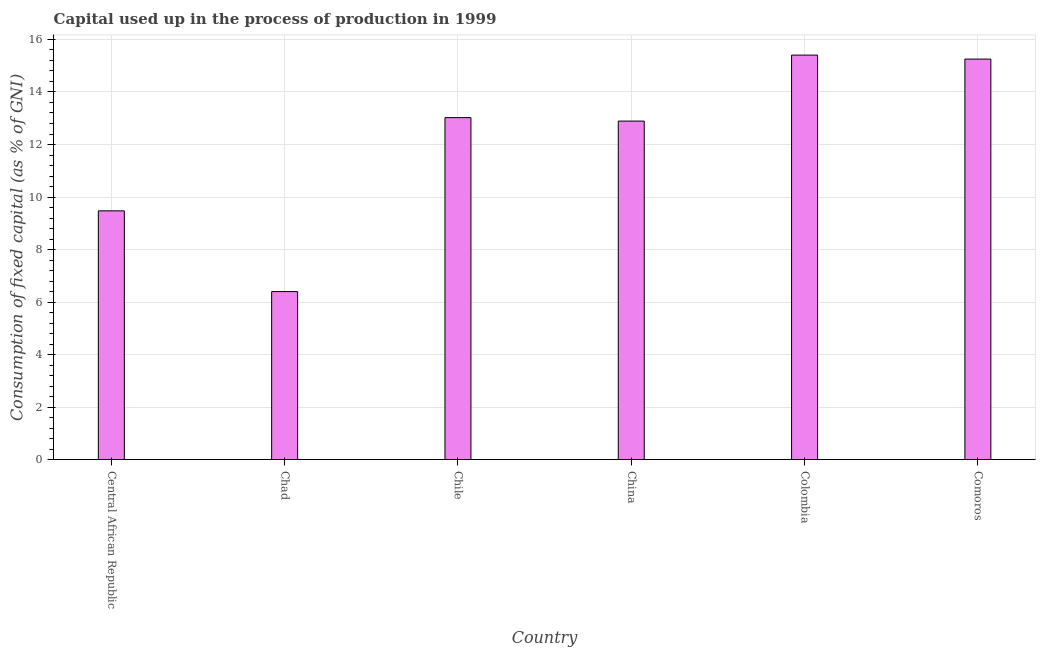Does the graph contain grids?
Keep it short and to the point. Yes. What is the title of the graph?
Offer a terse response. Capital used up in the process of production in 1999. What is the label or title of the Y-axis?
Make the answer very short. Consumption of fixed capital (as % of GNI). What is the consumption of fixed capital in Chad?
Offer a very short reply. 6.4. Across all countries, what is the maximum consumption of fixed capital?
Ensure brevity in your answer.  15.4. Across all countries, what is the minimum consumption of fixed capital?
Your response must be concise. 6.4. In which country was the consumption of fixed capital maximum?
Give a very brief answer. Colombia. In which country was the consumption of fixed capital minimum?
Provide a succinct answer. Chad. What is the sum of the consumption of fixed capital?
Your response must be concise. 72.45. What is the difference between the consumption of fixed capital in Central African Republic and Comoros?
Make the answer very short. -5.78. What is the average consumption of fixed capital per country?
Offer a very short reply. 12.07. What is the median consumption of fixed capital?
Provide a succinct answer. 12.96. What is the ratio of the consumption of fixed capital in Chad to that in China?
Provide a succinct answer. 0.5. Is the consumption of fixed capital in Chad less than that in Comoros?
Give a very brief answer. Yes. Is the difference between the consumption of fixed capital in Chad and Chile greater than the difference between any two countries?
Make the answer very short. No. What is the difference between the highest and the second highest consumption of fixed capital?
Provide a short and direct response. 0.15. Is the sum of the consumption of fixed capital in Chad and Comoros greater than the maximum consumption of fixed capital across all countries?
Provide a succinct answer. Yes. How many countries are there in the graph?
Give a very brief answer. 6. What is the difference between two consecutive major ticks on the Y-axis?
Offer a very short reply. 2. Are the values on the major ticks of Y-axis written in scientific E-notation?
Your response must be concise. No. What is the Consumption of fixed capital (as % of GNI) in Central African Republic?
Your answer should be compact. 9.47. What is the Consumption of fixed capital (as % of GNI) of Chad?
Ensure brevity in your answer.  6.4. What is the Consumption of fixed capital (as % of GNI) of Chile?
Keep it short and to the point. 13.02. What is the Consumption of fixed capital (as % of GNI) of China?
Provide a short and direct response. 12.89. What is the Consumption of fixed capital (as % of GNI) of Colombia?
Your response must be concise. 15.4. What is the Consumption of fixed capital (as % of GNI) of Comoros?
Make the answer very short. 15.25. What is the difference between the Consumption of fixed capital (as % of GNI) in Central African Republic and Chad?
Offer a very short reply. 3.07. What is the difference between the Consumption of fixed capital (as % of GNI) in Central African Republic and Chile?
Provide a succinct answer. -3.55. What is the difference between the Consumption of fixed capital (as % of GNI) in Central African Republic and China?
Give a very brief answer. -3.42. What is the difference between the Consumption of fixed capital (as % of GNI) in Central African Republic and Colombia?
Give a very brief answer. -5.93. What is the difference between the Consumption of fixed capital (as % of GNI) in Central African Republic and Comoros?
Your answer should be very brief. -5.78. What is the difference between the Consumption of fixed capital (as % of GNI) in Chad and Chile?
Keep it short and to the point. -6.62. What is the difference between the Consumption of fixed capital (as % of GNI) in Chad and China?
Offer a very short reply. -6.49. What is the difference between the Consumption of fixed capital (as % of GNI) in Chad and Colombia?
Ensure brevity in your answer.  -9. What is the difference between the Consumption of fixed capital (as % of GNI) in Chad and Comoros?
Give a very brief answer. -8.85. What is the difference between the Consumption of fixed capital (as % of GNI) in Chile and China?
Provide a succinct answer. 0.13. What is the difference between the Consumption of fixed capital (as % of GNI) in Chile and Colombia?
Make the answer very short. -2.38. What is the difference between the Consumption of fixed capital (as % of GNI) in Chile and Comoros?
Your answer should be compact. -2.23. What is the difference between the Consumption of fixed capital (as % of GNI) in China and Colombia?
Your response must be concise. -2.51. What is the difference between the Consumption of fixed capital (as % of GNI) in China and Comoros?
Offer a very short reply. -2.36. What is the difference between the Consumption of fixed capital (as % of GNI) in Colombia and Comoros?
Your response must be concise. 0.15. What is the ratio of the Consumption of fixed capital (as % of GNI) in Central African Republic to that in Chad?
Provide a short and direct response. 1.48. What is the ratio of the Consumption of fixed capital (as % of GNI) in Central African Republic to that in Chile?
Your response must be concise. 0.73. What is the ratio of the Consumption of fixed capital (as % of GNI) in Central African Republic to that in China?
Make the answer very short. 0.73. What is the ratio of the Consumption of fixed capital (as % of GNI) in Central African Republic to that in Colombia?
Provide a short and direct response. 0.61. What is the ratio of the Consumption of fixed capital (as % of GNI) in Central African Republic to that in Comoros?
Offer a very short reply. 0.62. What is the ratio of the Consumption of fixed capital (as % of GNI) in Chad to that in Chile?
Provide a succinct answer. 0.49. What is the ratio of the Consumption of fixed capital (as % of GNI) in Chad to that in China?
Offer a terse response. 0.5. What is the ratio of the Consumption of fixed capital (as % of GNI) in Chad to that in Colombia?
Your response must be concise. 0.42. What is the ratio of the Consumption of fixed capital (as % of GNI) in Chad to that in Comoros?
Ensure brevity in your answer.  0.42. What is the ratio of the Consumption of fixed capital (as % of GNI) in Chile to that in Colombia?
Provide a succinct answer. 0.84. What is the ratio of the Consumption of fixed capital (as % of GNI) in Chile to that in Comoros?
Offer a very short reply. 0.85. What is the ratio of the Consumption of fixed capital (as % of GNI) in China to that in Colombia?
Ensure brevity in your answer.  0.84. What is the ratio of the Consumption of fixed capital (as % of GNI) in China to that in Comoros?
Your answer should be very brief. 0.84. 